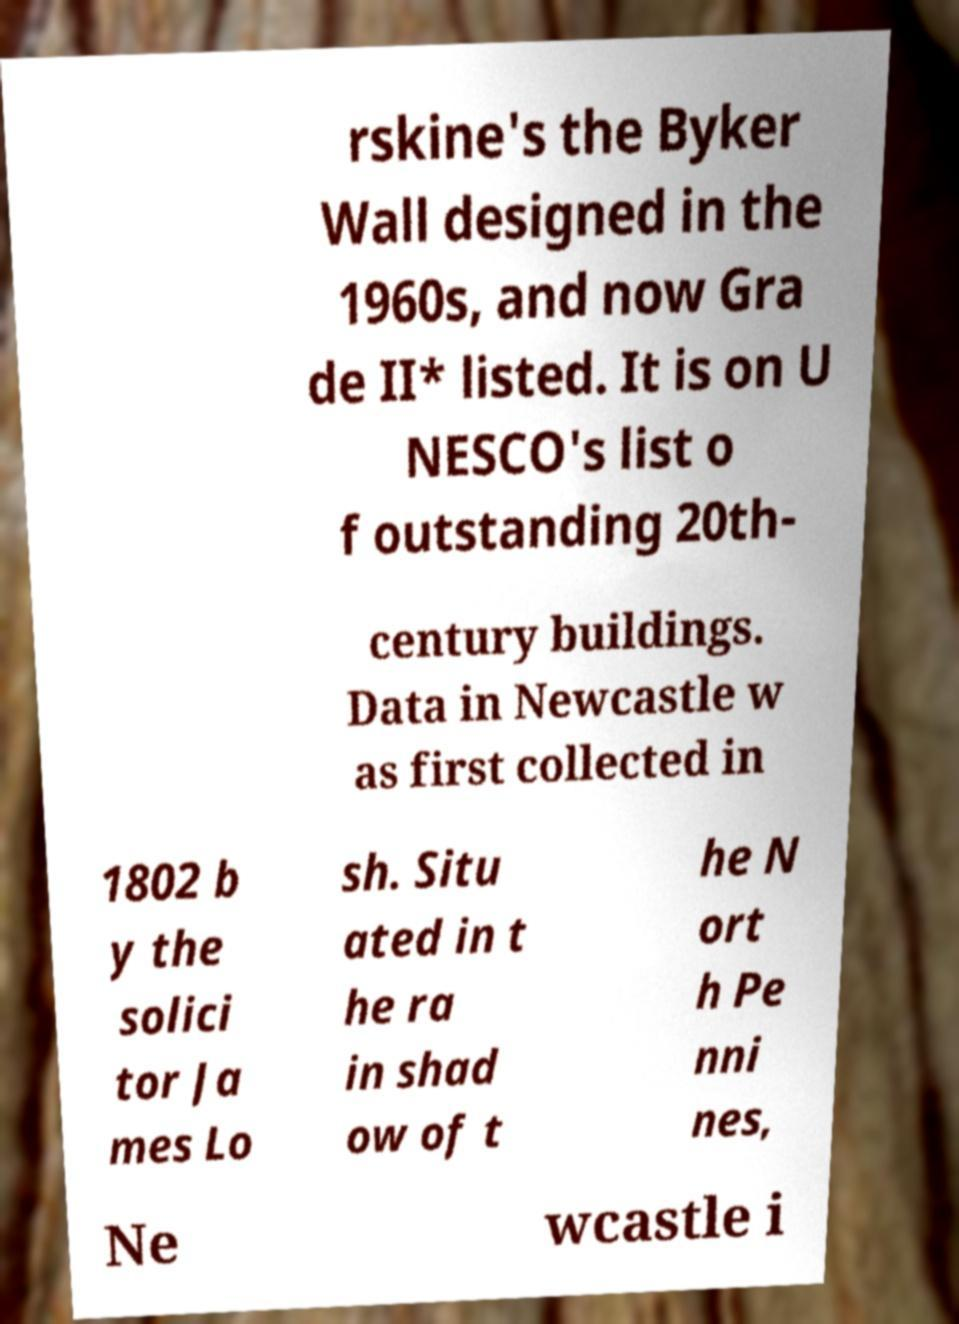For documentation purposes, I need the text within this image transcribed. Could you provide that? rskine's the Byker Wall designed in the 1960s, and now Gra de II* listed. It is on U NESCO's list o f outstanding 20th- century buildings. Data in Newcastle w as first collected in 1802 b y the solici tor Ja mes Lo sh. Situ ated in t he ra in shad ow of t he N ort h Pe nni nes, Ne wcastle i 